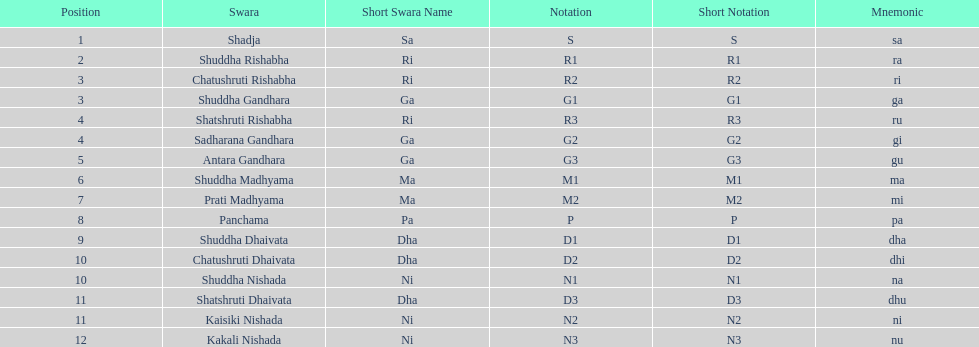On average how many of the swara have a short name that begin with d or g? 6. 